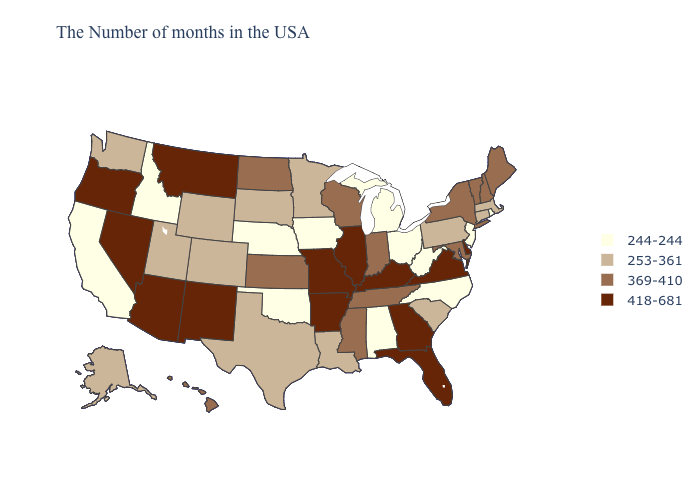Does the map have missing data?
Answer briefly. No. Among the states that border New Hampshire , does Vermont have the lowest value?
Write a very short answer. No. What is the value of New Mexico?
Quick response, please. 418-681. Does Rhode Island have the lowest value in the Northeast?
Give a very brief answer. Yes. Does the first symbol in the legend represent the smallest category?
Keep it brief. Yes. Name the states that have a value in the range 369-410?
Answer briefly. Maine, New Hampshire, Vermont, New York, Maryland, Indiana, Tennessee, Wisconsin, Mississippi, Kansas, North Dakota, Hawaii. What is the lowest value in states that border New York?
Answer briefly. 244-244. What is the highest value in the USA?
Concise answer only. 418-681. What is the value of West Virginia?
Short answer required. 244-244. What is the value of Colorado?
Short answer required. 253-361. What is the value of Oklahoma?
Give a very brief answer. 244-244. Does South Dakota have a higher value than Alabama?
Keep it brief. Yes. Name the states that have a value in the range 418-681?
Give a very brief answer. Delaware, Virginia, Florida, Georgia, Kentucky, Illinois, Missouri, Arkansas, New Mexico, Montana, Arizona, Nevada, Oregon. Name the states that have a value in the range 253-361?
Concise answer only. Massachusetts, Connecticut, Pennsylvania, South Carolina, Louisiana, Minnesota, Texas, South Dakota, Wyoming, Colorado, Utah, Washington, Alaska. What is the lowest value in states that border Kentucky?
Answer briefly. 244-244. 